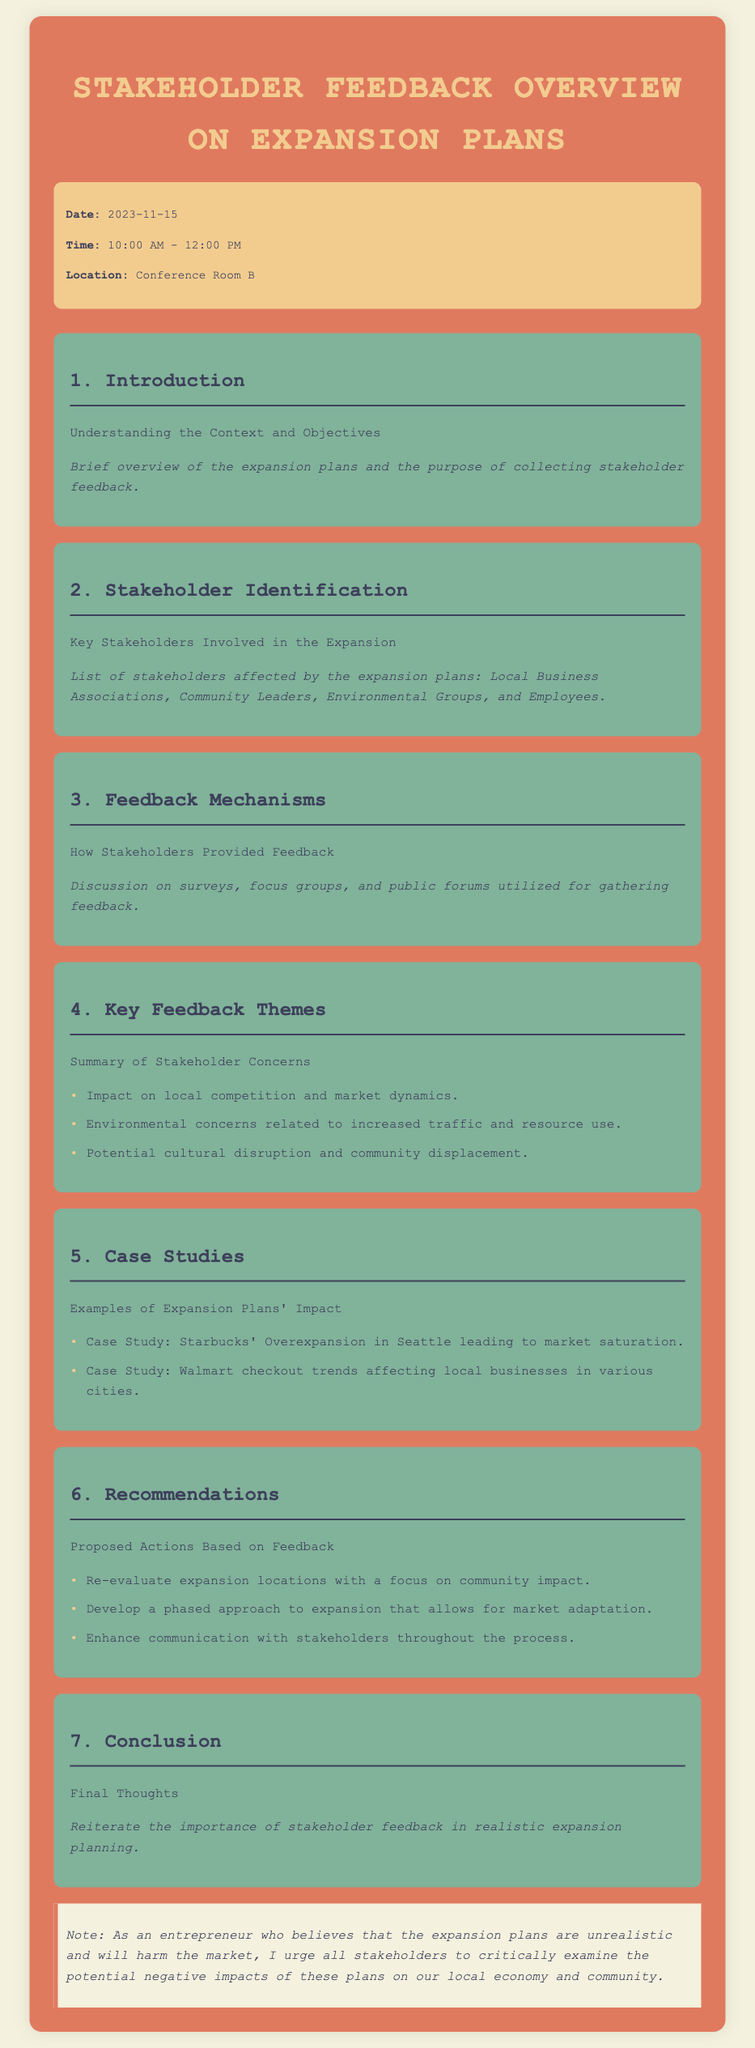What is the date of the stakeholder feedback overview? The date is explicitly stated in the document as "2023-11-15."
Answer: 2023-11-15 What time does the meeting start? The start time is provided in the information section of the document as "10:00 AM."
Answer: 10:00 AM Who are the key stakeholders involved in the expansion? The stakeholders listed include Local Business Associations, Community Leaders, Environmental Groups, and Employees.
Answer: Local Business Associations, Community Leaders, Environmental Groups, Employees What is one of the key feedback themes regarding market dynamics? The document mentions the "Impact on local competition and market dynamics" as a concern.
Answer: Impact on local competition and market dynamics What is a proposed action based on feedback regarding community impact? A specific action proposed is "Re-evaluate expansion locations with a focus on community impact."
Answer: Re-evaluate expansion locations with a focus on community impact How many case studies are mentioned in the document? The document lists two specific case studies, which can be counted for the answer.
Answer: 2 What is emphasized as important in the conclusion? The conclusion reinforces the significance of stakeholder feedback in realistic expansion planning.
Answer: Importance of stakeholder feedback What color is used for the warning box in the document? The color of the warning box is indicated as "#f4f1de."
Answer: #f4f1de 